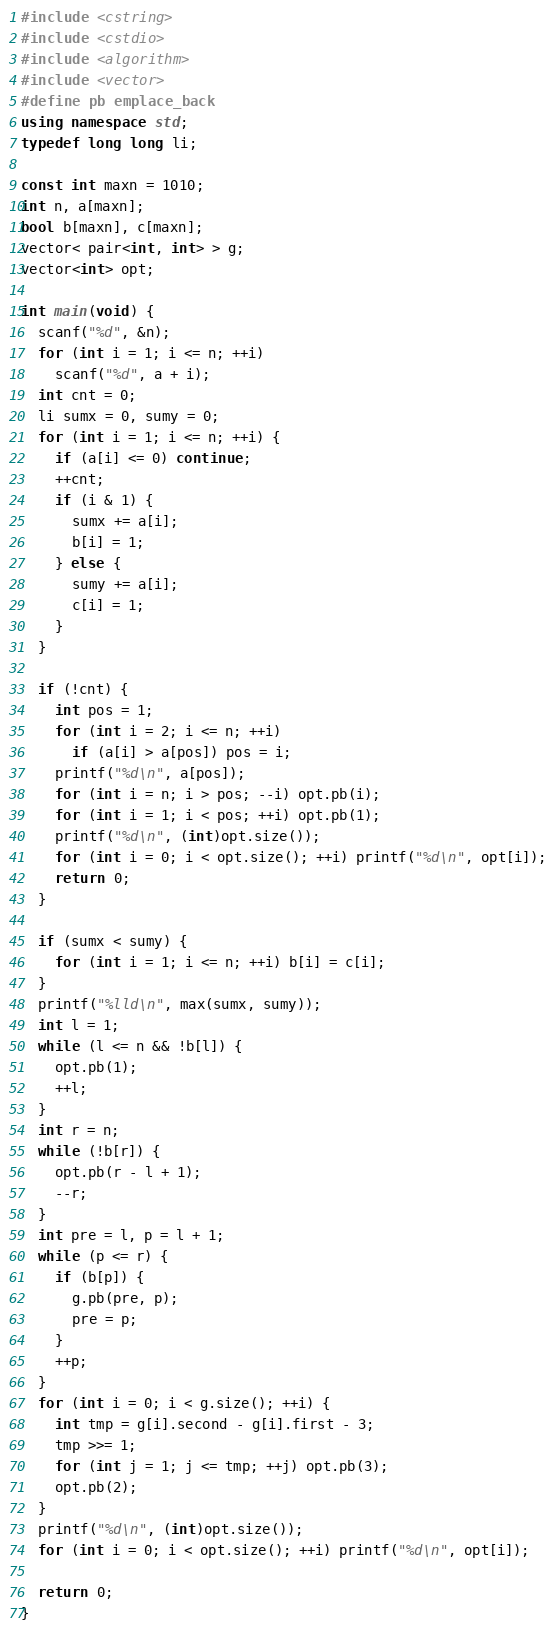<code> <loc_0><loc_0><loc_500><loc_500><_C++_>#include <cstring>
#include <cstdio>
#include <algorithm>
#include <vector>
#define pb emplace_back
using namespace std;
typedef long long li;

const int maxn = 1010;
int n, a[maxn];
bool b[maxn], c[maxn];
vector< pair<int, int> > g;
vector<int> opt;

int main(void) {
  scanf("%d", &n);
  for (int i = 1; i <= n; ++i)
    scanf("%d", a + i);
  int cnt = 0;
  li sumx = 0, sumy = 0;
  for (int i = 1; i <= n; ++i) {
    if (a[i] <= 0) continue;
    ++cnt;
    if (i & 1) {
      sumx += a[i];
      b[i] = 1;
    } else {
      sumy += a[i];
      c[i] = 1;
    }
  }
  
  if (!cnt) {
    int pos = 1;
    for (int i = 2; i <= n; ++i)
      if (a[i] > a[pos]) pos = i;
    printf("%d\n", a[pos]);
    for (int i = n; i > pos; --i) opt.pb(i);
    for (int i = 1; i < pos; ++i) opt.pb(1);
    printf("%d\n", (int)opt.size());
    for (int i = 0; i < opt.size(); ++i) printf("%d\n", opt[i]);
    return 0;
  }
  
  if (sumx < sumy) {
    for (int i = 1; i <= n; ++i) b[i] = c[i];
  }
  printf("%lld\n", max(sumx, sumy));
  int l = 1;
  while (l <= n && !b[l]) {
    opt.pb(1);
    ++l;
  }
  int r = n;
  while (!b[r]) {
    opt.pb(r - l + 1);
    --r;
  }
  int pre = l, p = l + 1;
  while (p <= r) {
    if (b[p]) {
      g.pb(pre, p);
      pre = p;
    }
    ++p;
  }
  for (int i = 0; i < g.size(); ++i) {
    int tmp = g[i].second - g[i].first - 3;
    tmp >>= 1;
    for (int j = 1; j <= tmp; ++j) opt.pb(3);
    opt.pb(2);
  }
  printf("%d\n", (int)opt.size());
  for (int i = 0; i < opt.size(); ++i) printf("%d\n", opt[i]);

  return 0;
}
</code> 